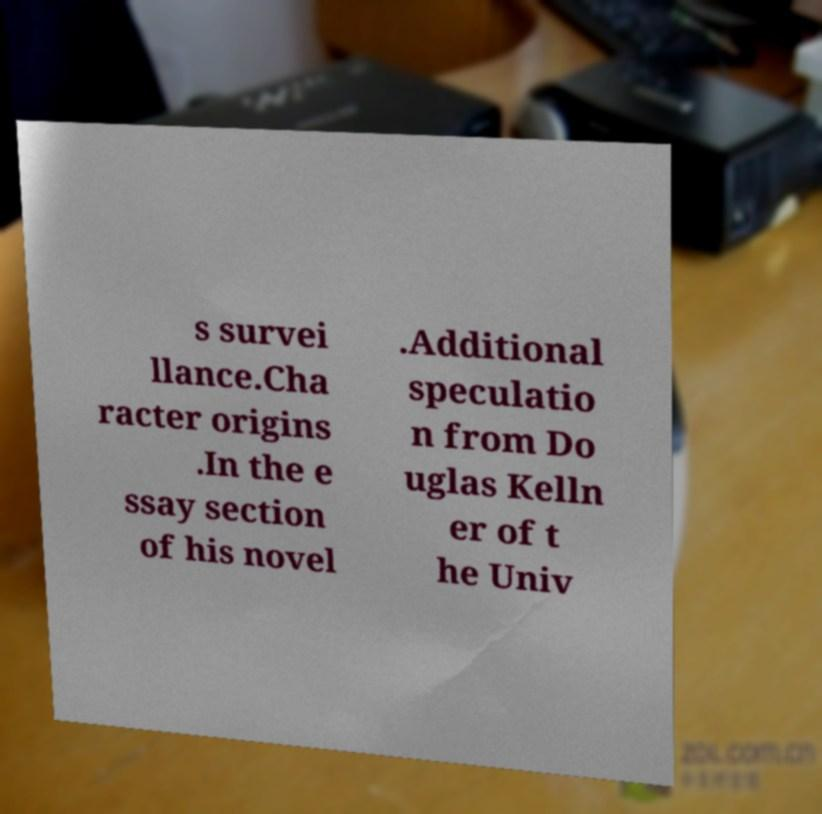For documentation purposes, I need the text within this image transcribed. Could you provide that? s survei llance.Cha racter origins .In the e ssay section of his novel .Additional speculatio n from Do uglas Kelln er of t he Univ 